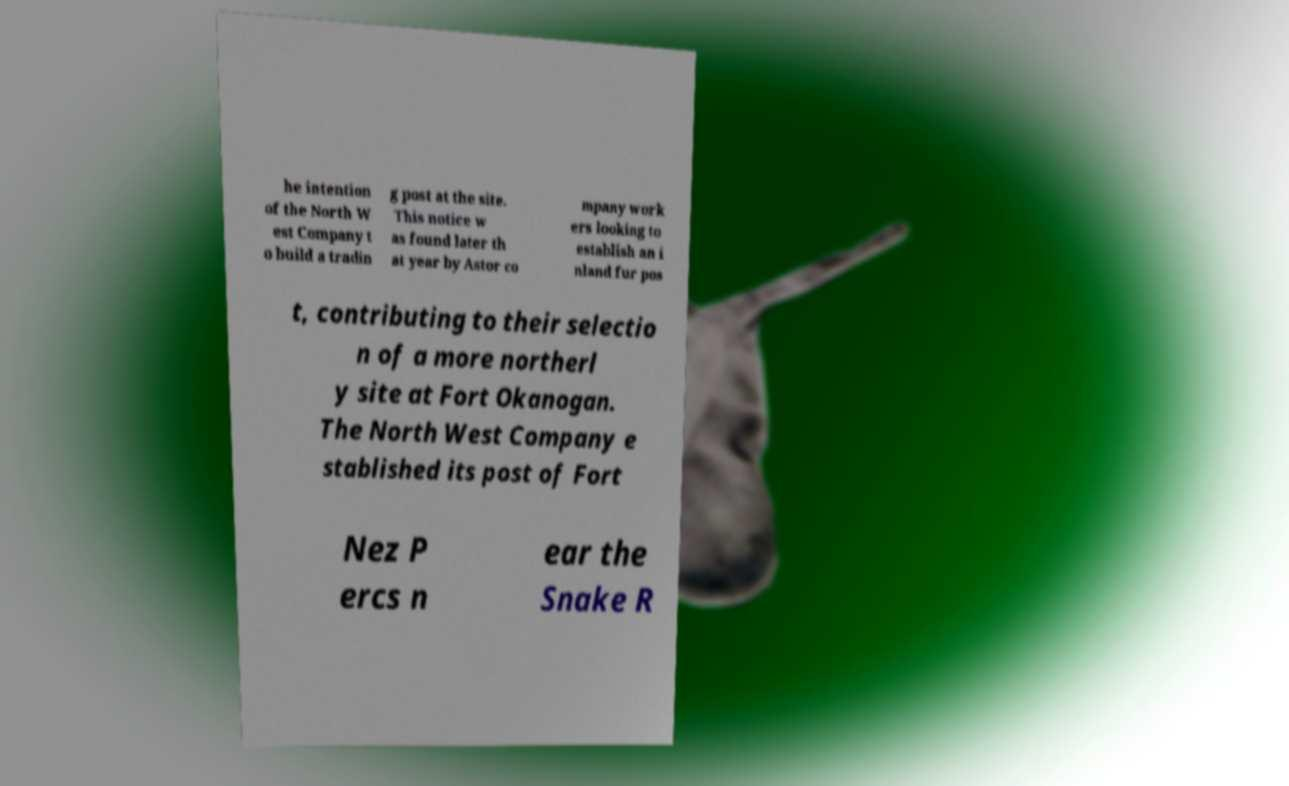Can you read and provide the text displayed in the image?This photo seems to have some interesting text. Can you extract and type it out for me? he intention of the North W est Company t o build a tradin g post at the site. This notice w as found later th at year by Astor co mpany work ers looking to establish an i nland fur pos t, contributing to their selectio n of a more northerl y site at Fort Okanogan. The North West Company e stablished its post of Fort Nez P ercs n ear the Snake R 